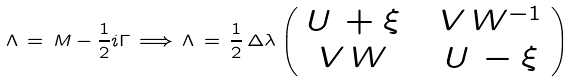Convert formula to latex. <formula><loc_0><loc_0><loc_500><loc_500>\Lambda \, = \, M - \frac { 1 } { 2 } i \Gamma \, \Longrightarrow \, \Lambda \, = \, \frac { 1 } { 2 } \, \Delta \lambda \left ( \begin{array} { c c c } U \, + { \xi } & \, & V \, W ^ { - 1 } \\ V \, W & \, & U \, - { \xi } \\ \end{array} \right )</formula> 